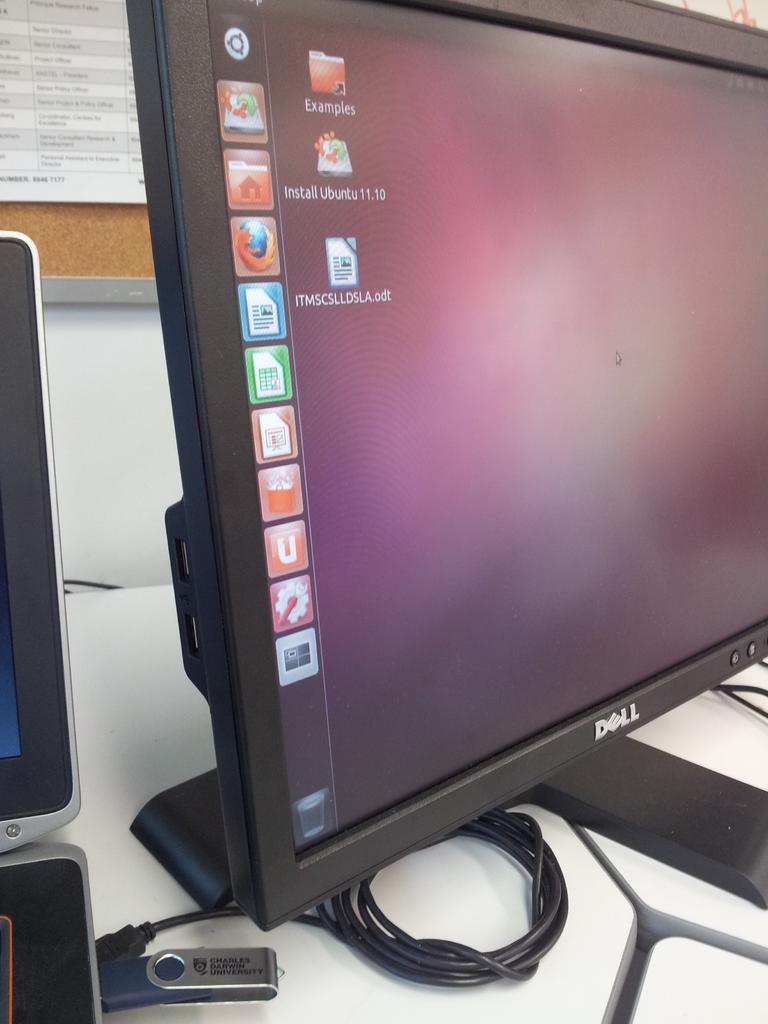How would you summarize this image in a sentence or two? In this image we can see a monitor. A pen drive and a wire connected to it. On the backside we can see a board, papers on it and a wall. 